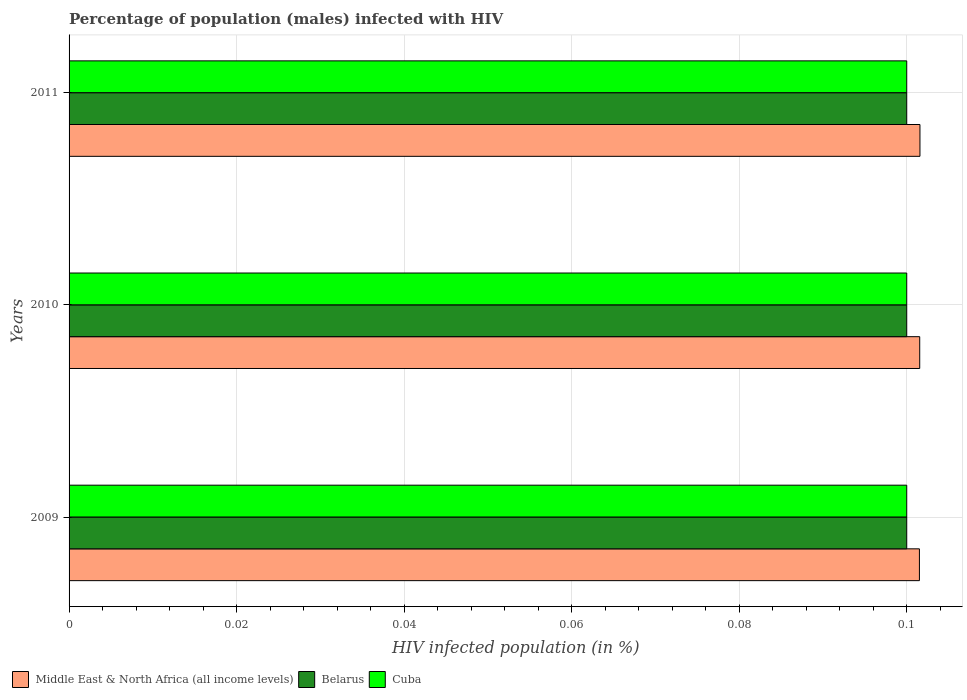How many different coloured bars are there?
Ensure brevity in your answer.  3. How many groups of bars are there?
Provide a succinct answer. 3. How many bars are there on the 2nd tick from the top?
Offer a terse response. 3. How many bars are there on the 1st tick from the bottom?
Make the answer very short. 3. What is the label of the 2nd group of bars from the top?
Make the answer very short. 2010. In how many cases, is the number of bars for a given year not equal to the number of legend labels?
Your response must be concise. 0. What is the percentage of HIV infected male population in Middle East & North Africa (all income levels) in 2009?
Your answer should be compact. 0.1. Across all years, what is the minimum percentage of HIV infected male population in Middle East & North Africa (all income levels)?
Offer a very short reply. 0.1. In which year was the percentage of HIV infected male population in Belarus maximum?
Provide a short and direct response. 2009. In which year was the percentage of HIV infected male population in Cuba minimum?
Provide a succinct answer. 2009. What is the total percentage of HIV infected male population in Belarus in the graph?
Offer a very short reply. 0.3. What is the difference between the percentage of HIV infected male population in Middle East & North Africa (all income levels) in 2009 and that in 2011?
Your answer should be compact. -6.304380411600863e-5. What is the difference between the percentage of HIV infected male population in Cuba in 2010 and the percentage of HIV infected male population in Middle East & North Africa (all income levels) in 2011?
Keep it short and to the point. -0. What is the average percentage of HIV infected male population in Cuba per year?
Offer a very short reply. 0.1. In the year 2010, what is the difference between the percentage of HIV infected male population in Belarus and percentage of HIV infected male population in Middle East & North Africa (all income levels)?
Your answer should be compact. -0. In how many years, is the percentage of HIV infected male population in Middle East & North Africa (all income levels) greater than 0.08 %?
Offer a terse response. 3. Is the difference between the percentage of HIV infected male population in Belarus in 2010 and 2011 greater than the difference between the percentage of HIV infected male population in Middle East & North Africa (all income levels) in 2010 and 2011?
Your response must be concise. Yes. What is the difference between the highest and the second highest percentage of HIV infected male population in Middle East & North Africa (all income levels)?
Give a very brief answer. 2.6701371837009602e-5. What is the difference between the highest and the lowest percentage of HIV infected male population in Cuba?
Give a very brief answer. 0. Is the sum of the percentage of HIV infected male population in Middle East & North Africa (all income levels) in 2010 and 2011 greater than the maximum percentage of HIV infected male population in Belarus across all years?
Your answer should be very brief. Yes. What does the 1st bar from the top in 2011 represents?
Offer a terse response. Cuba. What does the 2nd bar from the bottom in 2011 represents?
Ensure brevity in your answer.  Belarus. Is it the case that in every year, the sum of the percentage of HIV infected male population in Cuba and percentage of HIV infected male population in Belarus is greater than the percentage of HIV infected male population in Middle East & North Africa (all income levels)?
Ensure brevity in your answer.  Yes. How many bars are there?
Make the answer very short. 9. How many years are there in the graph?
Your response must be concise. 3. Does the graph contain grids?
Your answer should be compact. Yes. Where does the legend appear in the graph?
Your response must be concise. Bottom left. How are the legend labels stacked?
Keep it short and to the point. Horizontal. What is the title of the graph?
Keep it short and to the point. Percentage of population (males) infected with HIV. Does "Sudan" appear as one of the legend labels in the graph?
Your answer should be very brief. No. What is the label or title of the X-axis?
Your response must be concise. HIV infected population (in %). What is the label or title of the Y-axis?
Give a very brief answer. Years. What is the HIV infected population (in %) in Middle East & North Africa (all income levels) in 2009?
Your response must be concise. 0.1. What is the HIV infected population (in %) of Cuba in 2009?
Give a very brief answer. 0.1. What is the HIV infected population (in %) in Middle East & North Africa (all income levels) in 2010?
Ensure brevity in your answer.  0.1. What is the HIV infected population (in %) in Belarus in 2010?
Keep it short and to the point. 0.1. What is the HIV infected population (in %) in Middle East & North Africa (all income levels) in 2011?
Offer a very short reply. 0.1. What is the HIV infected population (in %) in Cuba in 2011?
Provide a short and direct response. 0.1. Across all years, what is the maximum HIV infected population (in %) of Middle East & North Africa (all income levels)?
Offer a very short reply. 0.1. Across all years, what is the maximum HIV infected population (in %) in Belarus?
Your answer should be compact. 0.1. Across all years, what is the minimum HIV infected population (in %) of Middle East & North Africa (all income levels)?
Provide a short and direct response. 0.1. Across all years, what is the minimum HIV infected population (in %) of Cuba?
Offer a terse response. 0.1. What is the total HIV infected population (in %) in Middle East & North Africa (all income levels) in the graph?
Your answer should be very brief. 0.3. What is the total HIV infected population (in %) in Cuba in the graph?
Make the answer very short. 0.3. What is the difference between the HIV infected population (in %) of Middle East & North Africa (all income levels) in 2009 and that in 2011?
Make the answer very short. -0. What is the difference between the HIV infected population (in %) of Belarus in 2009 and that in 2011?
Provide a short and direct response. 0. What is the difference between the HIV infected population (in %) in Middle East & North Africa (all income levels) in 2009 and the HIV infected population (in %) in Belarus in 2010?
Offer a very short reply. 0. What is the difference between the HIV infected population (in %) of Middle East & North Africa (all income levels) in 2009 and the HIV infected population (in %) of Cuba in 2010?
Offer a terse response. 0. What is the difference between the HIV infected population (in %) in Belarus in 2009 and the HIV infected population (in %) in Cuba in 2010?
Ensure brevity in your answer.  0. What is the difference between the HIV infected population (in %) of Middle East & North Africa (all income levels) in 2009 and the HIV infected population (in %) of Belarus in 2011?
Provide a succinct answer. 0. What is the difference between the HIV infected population (in %) in Middle East & North Africa (all income levels) in 2009 and the HIV infected population (in %) in Cuba in 2011?
Keep it short and to the point. 0. What is the difference between the HIV infected population (in %) of Belarus in 2009 and the HIV infected population (in %) of Cuba in 2011?
Your response must be concise. 0. What is the difference between the HIV infected population (in %) in Middle East & North Africa (all income levels) in 2010 and the HIV infected population (in %) in Belarus in 2011?
Your answer should be compact. 0. What is the difference between the HIV infected population (in %) in Middle East & North Africa (all income levels) in 2010 and the HIV infected population (in %) in Cuba in 2011?
Offer a very short reply. 0. What is the difference between the HIV infected population (in %) in Belarus in 2010 and the HIV infected population (in %) in Cuba in 2011?
Offer a very short reply. 0. What is the average HIV infected population (in %) in Middle East & North Africa (all income levels) per year?
Provide a succinct answer. 0.1. What is the average HIV infected population (in %) of Belarus per year?
Make the answer very short. 0.1. What is the average HIV infected population (in %) in Cuba per year?
Your answer should be very brief. 0.1. In the year 2009, what is the difference between the HIV infected population (in %) of Middle East & North Africa (all income levels) and HIV infected population (in %) of Belarus?
Make the answer very short. 0. In the year 2009, what is the difference between the HIV infected population (in %) in Middle East & North Africa (all income levels) and HIV infected population (in %) in Cuba?
Keep it short and to the point. 0. In the year 2010, what is the difference between the HIV infected population (in %) of Middle East & North Africa (all income levels) and HIV infected population (in %) of Belarus?
Offer a very short reply. 0. In the year 2010, what is the difference between the HIV infected population (in %) of Middle East & North Africa (all income levels) and HIV infected population (in %) of Cuba?
Make the answer very short. 0. In the year 2010, what is the difference between the HIV infected population (in %) of Belarus and HIV infected population (in %) of Cuba?
Offer a very short reply. 0. In the year 2011, what is the difference between the HIV infected population (in %) in Middle East & North Africa (all income levels) and HIV infected population (in %) in Belarus?
Provide a succinct answer. 0. In the year 2011, what is the difference between the HIV infected population (in %) of Middle East & North Africa (all income levels) and HIV infected population (in %) of Cuba?
Your response must be concise. 0. In the year 2011, what is the difference between the HIV infected population (in %) of Belarus and HIV infected population (in %) of Cuba?
Offer a terse response. 0. What is the ratio of the HIV infected population (in %) of Belarus in 2009 to that in 2010?
Ensure brevity in your answer.  1. What is the ratio of the HIV infected population (in %) of Belarus in 2009 to that in 2011?
Your answer should be compact. 1. What is the ratio of the HIV infected population (in %) in Cuba in 2009 to that in 2011?
Your answer should be very brief. 1. What is the ratio of the HIV infected population (in %) in Middle East & North Africa (all income levels) in 2010 to that in 2011?
Give a very brief answer. 1. What is the difference between the highest and the second highest HIV infected population (in %) of Middle East & North Africa (all income levels)?
Provide a short and direct response. 0. What is the difference between the highest and the second highest HIV infected population (in %) in Cuba?
Provide a succinct answer. 0. What is the difference between the highest and the lowest HIV infected population (in %) in Middle East & North Africa (all income levels)?
Provide a short and direct response. 0. What is the difference between the highest and the lowest HIV infected population (in %) in Cuba?
Offer a terse response. 0. 